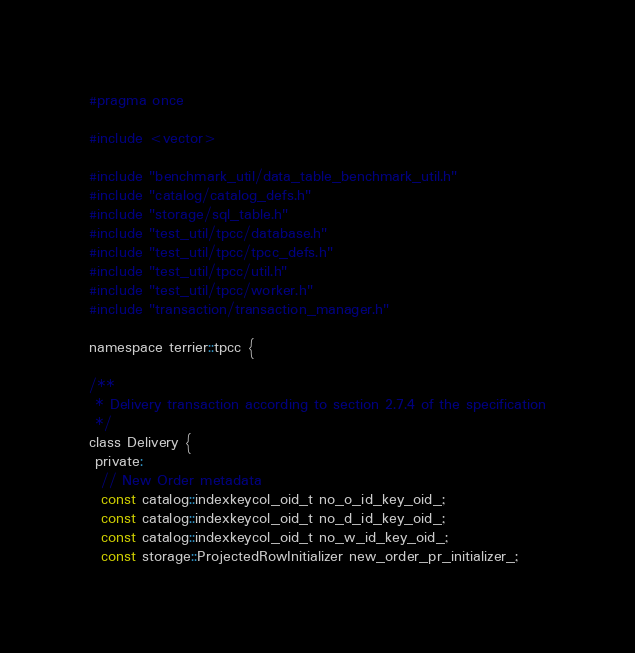Convert code to text. <code><loc_0><loc_0><loc_500><loc_500><_C_>#pragma once

#include <vector>

#include "benchmark_util/data_table_benchmark_util.h"
#include "catalog/catalog_defs.h"
#include "storage/sql_table.h"
#include "test_util/tpcc/database.h"
#include "test_util/tpcc/tpcc_defs.h"
#include "test_util/tpcc/util.h"
#include "test_util/tpcc/worker.h"
#include "transaction/transaction_manager.h"

namespace terrier::tpcc {

/**
 * Delivery transaction according to section 2.7.4 of the specification
 */
class Delivery {
 private:
  // New Order metadata
  const catalog::indexkeycol_oid_t no_o_id_key_oid_;
  const catalog::indexkeycol_oid_t no_d_id_key_oid_;
  const catalog::indexkeycol_oid_t no_w_id_key_oid_;
  const storage::ProjectedRowInitializer new_order_pr_initializer_;</code> 